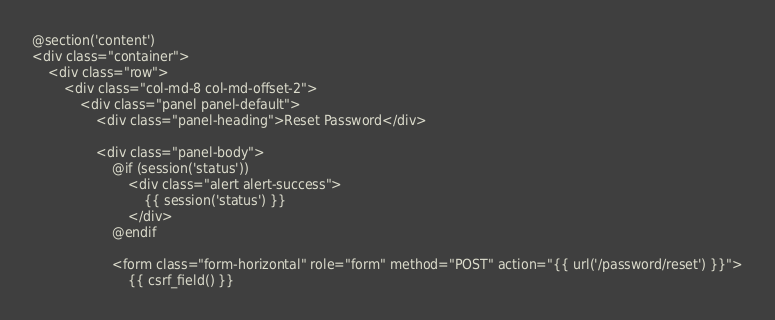Convert code to text. <code><loc_0><loc_0><loc_500><loc_500><_PHP_>@section('content')
<div class="container">
    <div class="row">
        <div class="col-md-8 col-md-offset-2">
            <div class="panel panel-default">
                <div class="panel-heading">Reset Password</div>

                <div class="panel-body">
                    @if (session('status'))
                        <div class="alert alert-success">
                            {{ session('status') }}
                        </div>
                    @endif

                    <form class="form-horizontal" role="form" method="POST" action="{{ url('/password/reset') }}">
                        {{ csrf_field() }}
</code> 